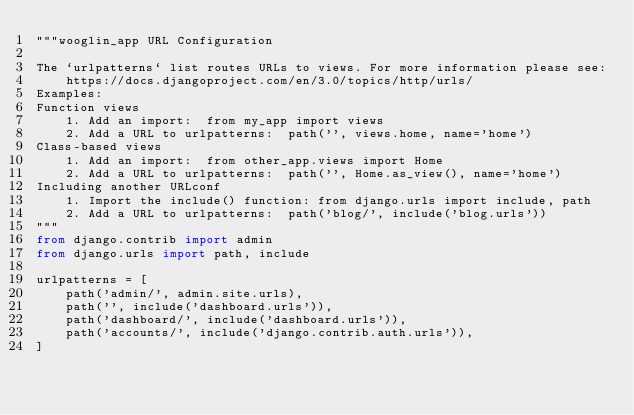Convert code to text. <code><loc_0><loc_0><loc_500><loc_500><_Python_>"""wooglin_app URL Configuration

The `urlpatterns` list routes URLs to views. For more information please see:
    https://docs.djangoproject.com/en/3.0/topics/http/urls/
Examples:
Function views
    1. Add an import:  from my_app import views
    2. Add a URL to urlpatterns:  path('', views.home, name='home')
Class-based views
    1. Add an import:  from other_app.views import Home
    2. Add a URL to urlpatterns:  path('', Home.as_view(), name='home')
Including another URLconf
    1. Import the include() function: from django.urls import include, path
    2. Add a URL to urlpatterns:  path('blog/', include('blog.urls'))
"""
from django.contrib import admin
from django.urls import path, include

urlpatterns = [
    path('admin/', admin.site.urls),
    path('', include('dashboard.urls')),
    path('dashboard/', include('dashboard.urls')),
    path('accounts/', include('django.contrib.auth.urls')),
]
</code> 